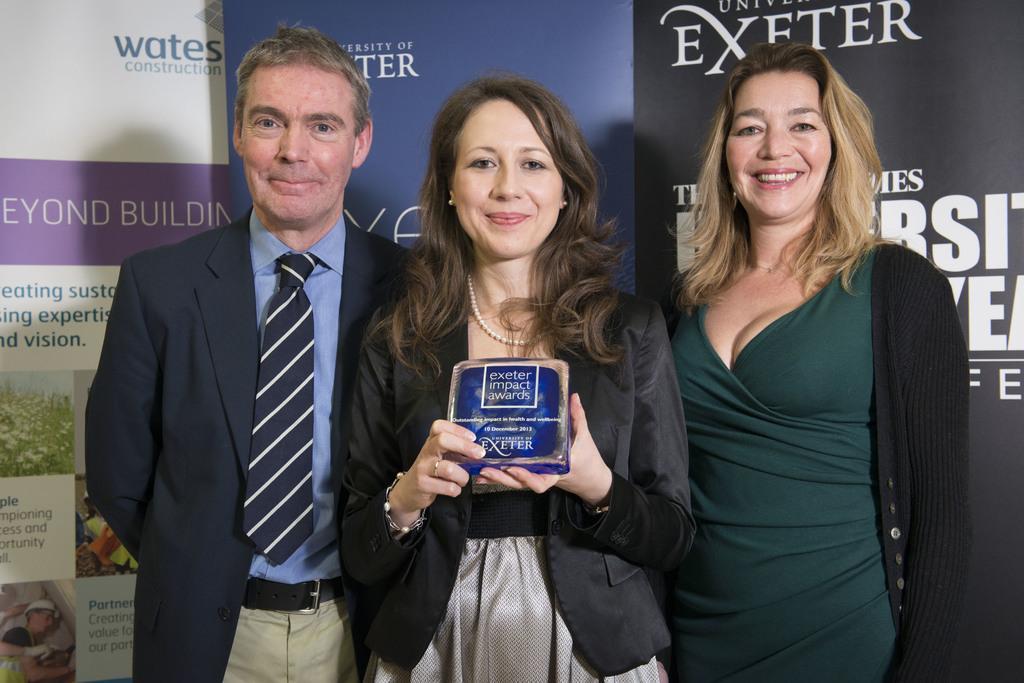Please provide a concise description of this image. In this image I can see three people with different color dresses. I can see one person is holding the blue color object. In the background I can see the banner and something is written on it. 